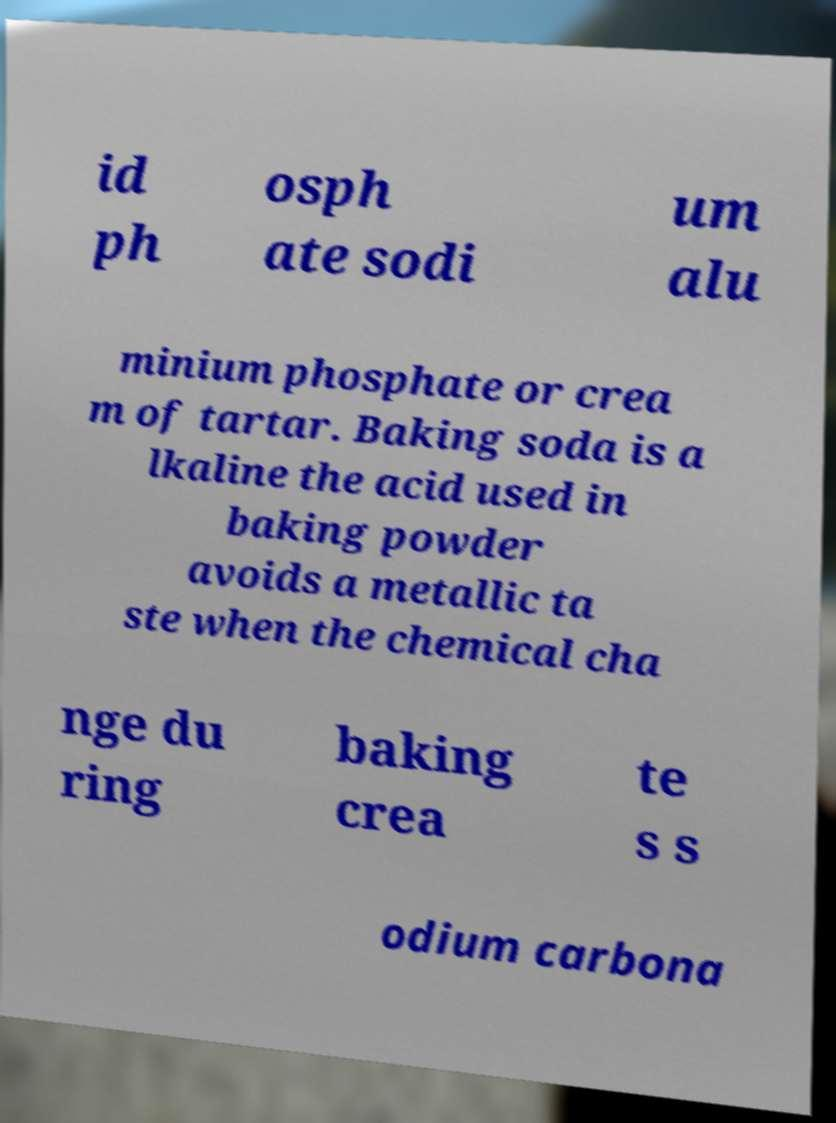For documentation purposes, I need the text within this image transcribed. Could you provide that? id ph osph ate sodi um alu minium phosphate or crea m of tartar. Baking soda is a lkaline the acid used in baking powder avoids a metallic ta ste when the chemical cha nge du ring baking crea te s s odium carbona 